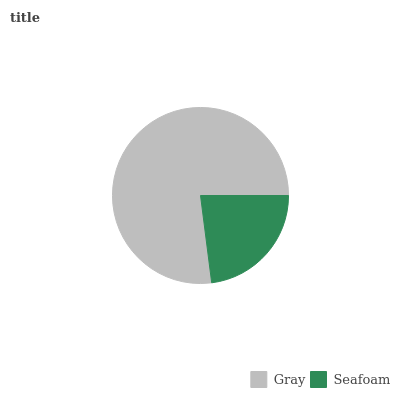Is Seafoam the minimum?
Answer yes or no. Yes. Is Gray the maximum?
Answer yes or no. Yes. Is Seafoam the maximum?
Answer yes or no. No. Is Gray greater than Seafoam?
Answer yes or no. Yes. Is Seafoam less than Gray?
Answer yes or no. Yes. Is Seafoam greater than Gray?
Answer yes or no. No. Is Gray less than Seafoam?
Answer yes or no. No. Is Gray the high median?
Answer yes or no. Yes. Is Seafoam the low median?
Answer yes or no. Yes. Is Seafoam the high median?
Answer yes or no. No. Is Gray the low median?
Answer yes or no. No. 